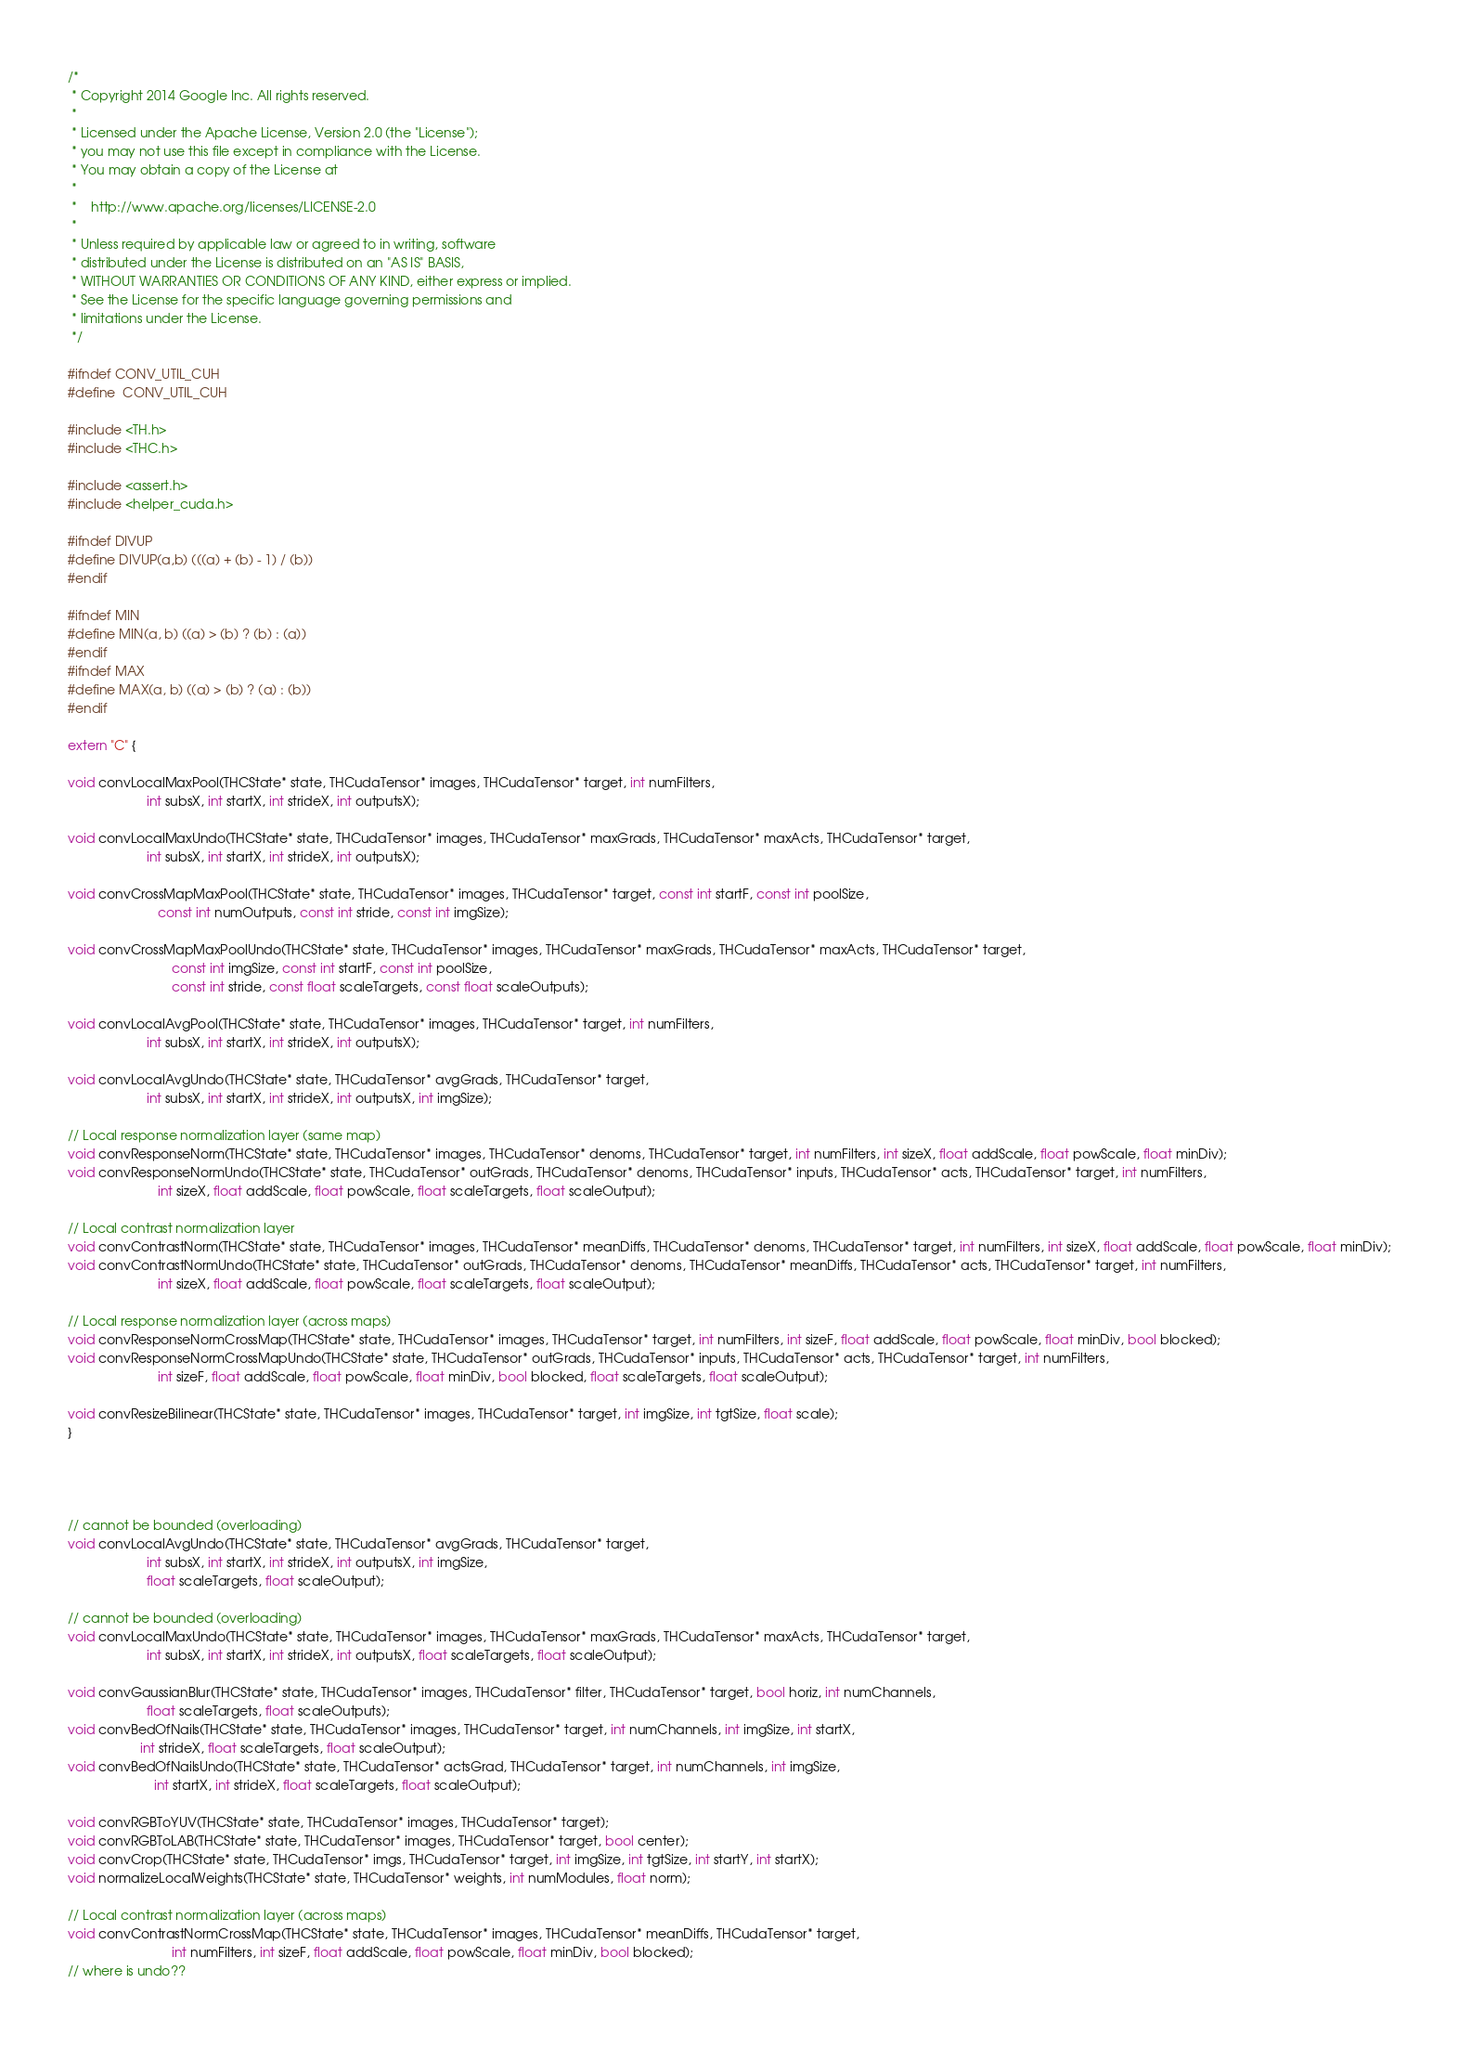Convert code to text. <code><loc_0><loc_0><loc_500><loc_500><_Cuda_>/*
 * Copyright 2014 Google Inc. All rights reserved.
 *
 * Licensed under the Apache License, Version 2.0 (the "License");
 * you may not use this file except in compliance with the License.
 * You may obtain a copy of the License at
 *
 *    http://www.apache.org/licenses/LICENSE-2.0
 *
 * Unless required by applicable law or agreed to in writing, software
 * distributed under the License is distributed on an "AS IS" BASIS,
 * WITHOUT WARRANTIES OR CONDITIONS OF ANY KIND, either express or implied.
 * See the License for the specific language governing permissions and
 * limitations under the License.
 */

#ifndef CONV_UTIL_CUH
#define	CONV_UTIL_CUH

#include <TH.h>
#include <THC.h>

#include <assert.h>
#include <helper_cuda.h>

#ifndef DIVUP
#define DIVUP(a,b) (((a) + (b) - 1) / (b))
#endif

#ifndef MIN
#define MIN(a, b) ((a) > (b) ? (b) : (a))
#endif
#ifndef MAX
#define MAX(a, b) ((a) > (b) ? (a) : (b))
#endif

extern "C" {

void convLocalMaxPool(THCState* state, THCudaTensor* images, THCudaTensor* target, int numFilters,
                      int subsX, int startX, int strideX, int outputsX);

void convLocalMaxUndo(THCState* state, THCudaTensor* images, THCudaTensor* maxGrads, THCudaTensor* maxActs, THCudaTensor* target,
                      int subsX, int startX, int strideX, int outputsX);

void convCrossMapMaxPool(THCState* state, THCudaTensor* images, THCudaTensor* target, const int startF, const int poolSize,
                         const int numOutputs, const int stride, const int imgSize);

void convCrossMapMaxPoolUndo(THCState* state, THCudaTensor* images, THCudaTensor* maxGrads, THCudaTensor* maxActs, THCudaTensor* target,
                             const int imgSize, const int startF, const int poolSize,
                             const int stride, const float scaleTargets, const float scaleOutputs);

void convLocalAvgPool(THCState* state, THCudaTensor* images, THCudaTensor* target, int numFilters,
                      int subsX, int startX, int strideX, int outputsX);

void convLocalAvgUndo(THCState* state, THCudaTensor* avgGrads, THCudaTensor* target,
                      int subsX, int startX, int strideX, int outputsX, int imgSize);

// Local response normalization layer (same map)
void convResponseNorm(THCState* state, THCudaTensor* images, THCudaTensor* denoms, THCudaTensor* target, int numFilters, int sizeX, float addScale, float powScale, float minDiv);
void convResponseNormUndo(THCState* state, THCudaTensor* outGrads, THCudaTensor* denoms, THCudaTensor* inputs, THCudaTensor* acts, THCudaTensor* target, int numFilters,
                         int sizeX, float addScale, float powScale, float scaleTargets, float scaleOutput);

// Local contrast normalization layer
void convContrastNorm(THCState* state, THCudaTensor* images, THCudaTensor* meanDiffs, THCudaTensor* denoms, THCudaTensor* target, int numFilters, int sizeX, float addScale, float powScale, float minDiv);
void convContrastNormUndo(THCState* state, THCudaTensor* outGrads, THCudaTensor* denoms, THCudaTensor* meanDiffs, THCudaTensor* acts, THCudaTensor* target, int numFilters,
                         int sizeX, float addScale, float powScale, float scaleTargets, float scaleOutput);

// Local response normalization layer (across maps)
void convResponseNormCrossMap(THCState* state, THCudaTensor* images, THCudaTensor* target, int numFilters, int sizeF, float addScale, float powScale, float minDiv, bool blocked);
void convResponseNormCrossMapUndo(THCState* state, THCudaTensor* outGrads, THCudaTensor* inputs, THCudaTensor* acts, THCudaTensor* target, int numFilters,
                         int sizeF, float addScale, float powScale, float minDiv, bool blocked, float scaleTargets, float scaleOutput);

void convResizeBilinear(THCState* state, THCudaTensor* images, THCudaTensor* target, int imgSize, int tgtSize, float scale);
}




// cannot be bounded (overloading)
void convLocalAvgUndo(THCState* state, THCudaTensor* avgGrads, THCudaTensor* target,
                      int subsX, int startX, int strideX, int outputsX, int imgSize,
                      float scaleTargets, float scaleOutput);

// cannot be bounded (overloading)
void convLocalMaxUndo(THCState* state, THCudaTensor* images, THCudaTensor* maxGrads, THCudaTensor* maxActs, THCudaTensor* target,
                      int subsX, int startX, int strideX, int outputsX, float scaleTargets, float scaleOutput);

void convGaussianBlur(THCState* state, THCudaTensor* images, THCudaTensor* filter, THCudaTensor* target, bool horiz, int numChannels,
                      float scaleTargets, float scaleOutputs);
void convBedOfNails(THCState* state, THCudaTensor* images, THCudaTensor* target, int numChannels, int imgSize, int startX,
                    int strideX, float scaleTargets, float scaleOutput);
void convBedOfNailsUndo(THCState* state, THCudaTensor* actsGrad, THCudaTensor* target, int numChannels, int imgSize,
                        int startX, int strideX, float scaleTargets, float scaleOutput);

void convRGBToYUV(THCState* state, THCudaTensor* images, THCudaTensor* target);
void convRGBToLAB(THCState* state, THCudaTensor* images, THCudaTensor* target, bool center);
void convCrop(THCState* state, THCudaTensor* imgs, THCudaTensor* target, int imgSize, int tgtSize, int startY, int startX);
void normalizeLocalWeights(THCState* state, THCudaTensor* weights, int numModules, float norm);

// Local contrast normalization layer (across maps)
void convContrastNormCrossMap(THCState* state, THCudaTensor* images, THCudaTensor* meanDiffs, THCudaTensor* target,
                             int numFilters, int sizeF, float addScale, float powScale, float minDiv, bool blocked);
// where is undo??
</code> 